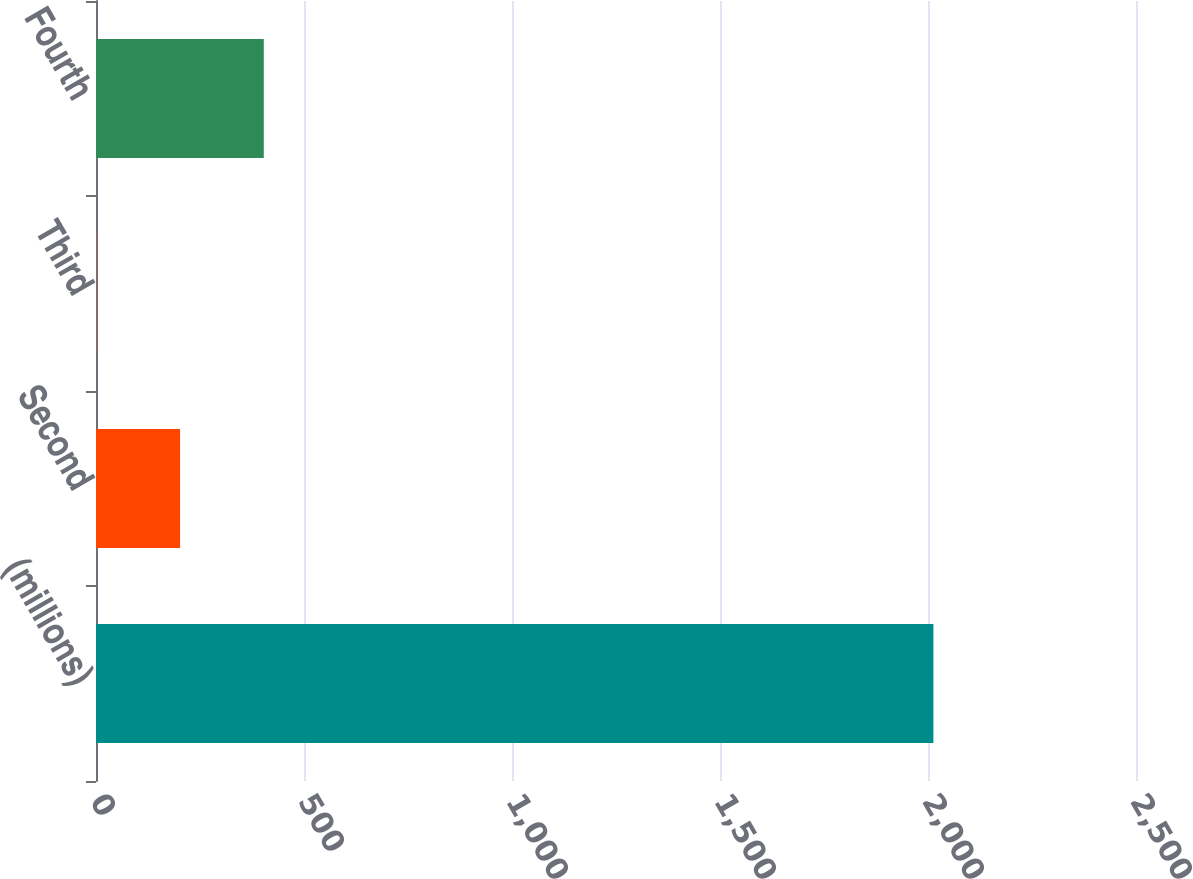<chart> <loc_0><loc_0><loc_500><loc_500><bar_chart><fcel>(millions)<fcel>Second<fcel>Third<fcel>Fourth<nl><fcel>2013<fcel>202.11<fcel>0.9<fcel>403.32<nl></chart> 